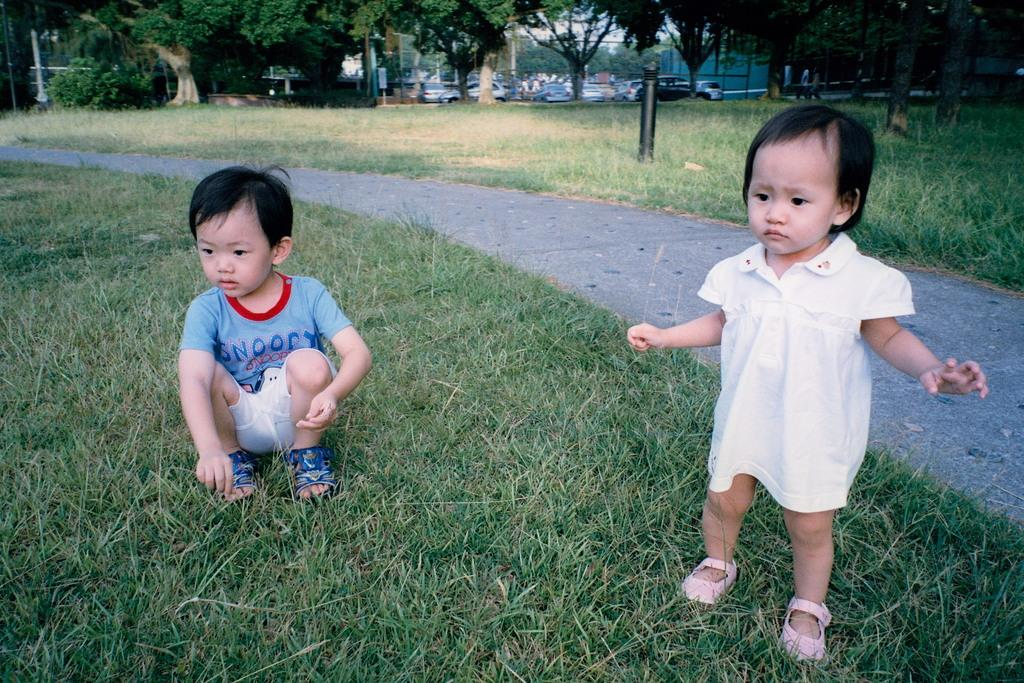<image>
Offer a succinct explanation of the picture presented. A little boy with a Snoopy shirt crouches on the grass. 